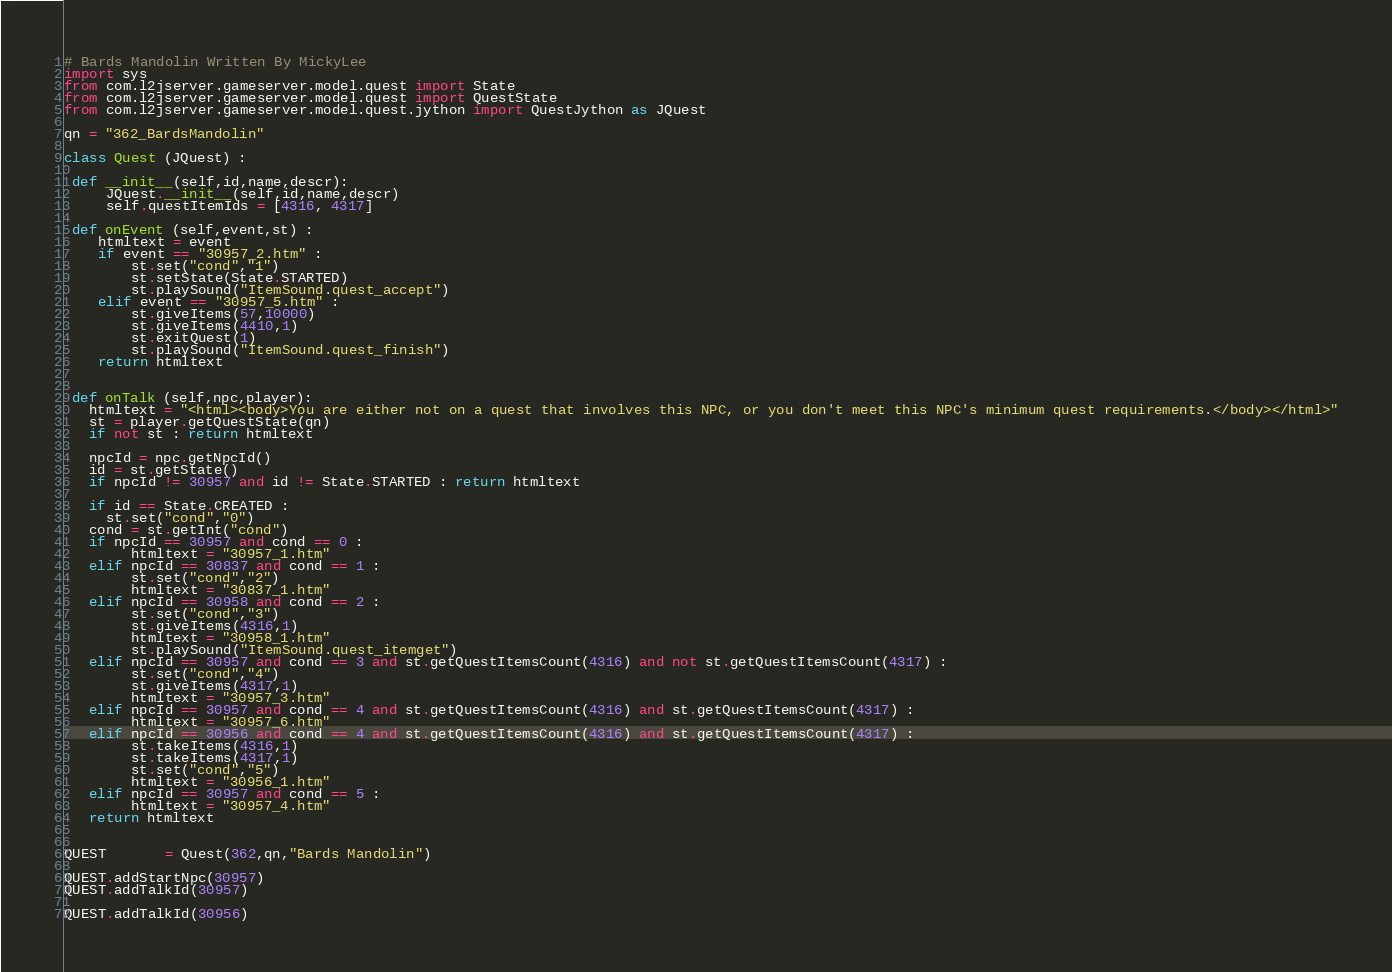<code> <loc_0><loc_0><loc_500><loc_500><_Python_># Bards Mandolin Written By MickyLee
import sys
from com.l2jserver.gameserver.model.quest import State
from com.l2jserver.gameserver.model.quest import QuestState
from com.l2jserver.gameserver.model.quest.jython import QuestJython as JQuest

qn = "362_BardsMandolin"

class Quest (JQuest) :

 def __init__(self,id,name,descr):
     JQuest.__init__(self,id,name,descr)
     self.questItemIds = [4316, 4317]

 def onEvent (self,event,st) :
    htmltext = event
    if event == "30957_2.htm" :
        st.set("cond","1")
        st.setState(State.STARTED)
        st.playSound("ItemSound.quest_accept")
    elif event == "30957_5.htm" :
        st.giveItems(57,10000)
        st.giveItems(4410,1)
        st.exitQuest(1)
        st.playSound("ItemSound.quest_finish")
    return htmltext


 def onTalk (self,npc,player):
   htmltext = "<html><body>You are either not on a quest that involves this NPC, or you don't meet this NPC's minimum quest requirements.</body></html>"
   st = player.getQuestState(qn)
   if not st : return htmltext

   npcId = npc.getNpcId()
   id = st.getState()
   if npcId != 30957 and id != State.STARTED : return htmltext

   if id == State.CREATED :
     st.set("cond","0")
   cond = st.getInt("cond")
   if npcId == 30957 and cond == 0 :
        htmltext = "30957_1.htm"
   elif npcId == 30837 and cond == 1 :
        st.set("cond","2")
        htmltext = "30837_1.htm"
   elif npcId == 30958 and cond == 2 :
        st.set("cond","3")
        st.giveItems(4316,1)
        htmltext = "30958_1.htm"
        st.playSound("ItemSound.quest_itemget")
   elif npcId == 30957 and cond == 3 and st.getQuestItemsCount(4316) and not st.getQuestItemsCount(4317) :
        st.set("cond","4")
        st.giveItems(4317,1)
        htmltext = "30957_3.htm"
   elif npcId == 30957 and cond == 4 and st.getQuestItemsCount(4316) and st.getQuestItemsCount(4317) :
        htmltext = "30957_6.htm"
   elif npcId == 30956 and cond == 4 and st.getQuestItemsCount(4316) and st.getQuestItemsCount(4317) :
        st.takeItems(4316,1)
        st.takeItems(4317,1)
        st.set("cond","5")
        htmltext = "30956_1.htm"
   elif npcId == 30957 and cond == 5 :
        htmltext = "30957_4.htm"
   return htmltext


QUEST       = Quest(362,qn,"Bards Mandolin")

QUEST.addStartNpc(30957)
QUEST.addTalkId(30957)

QUEST.addTalkId(30956)</code> 